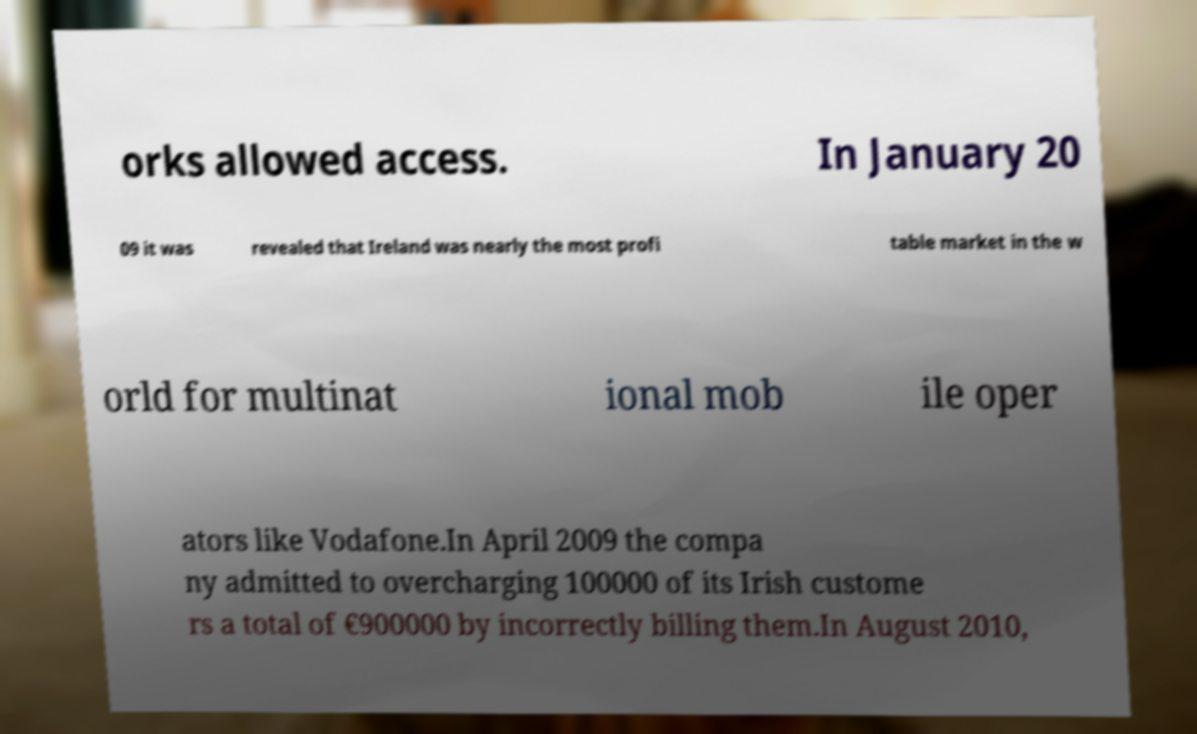For documentation purposes, I need the text within this image transcribed. Could you provide that? orks allowed access. In January 20 09 it was revealed that Ireland was nearly the most profi table market in the w orld for multinat ional mob ile oper ators like Vodafone.In April 2009 the compa ny admitted to overcharging 100000 of its Irish custome rs a total of €900000 by incorrectly billing them.In August 2010, 